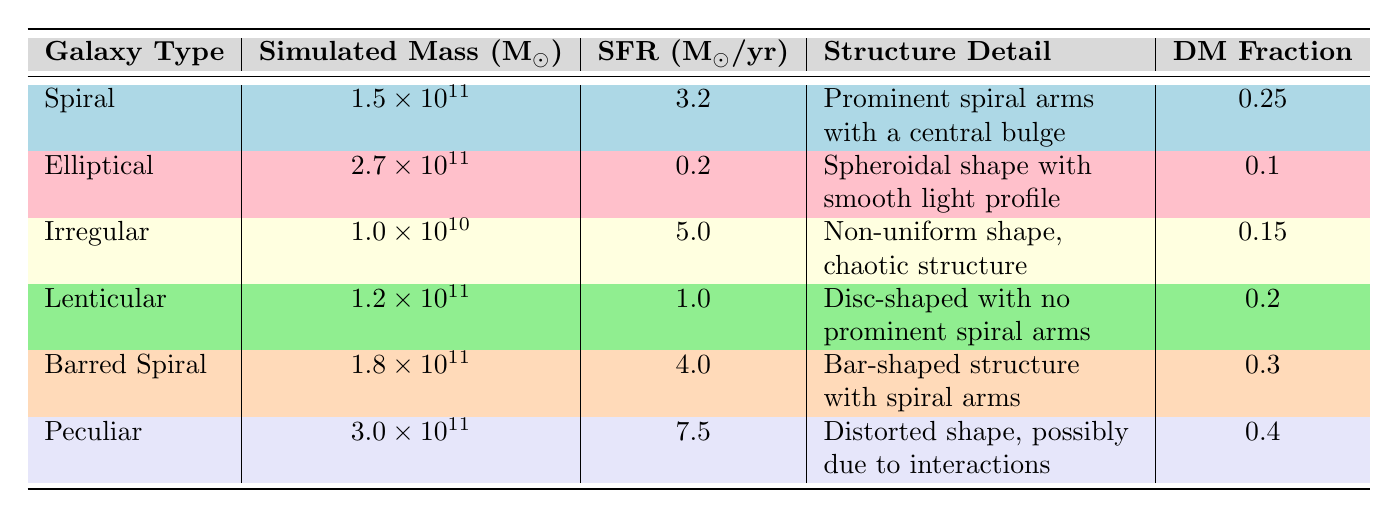What is the structure detail of the Spiral galaxy? According to the table, the structure detail for the Spiral galaxy is described as "Prominent spiral arms with a central bulge".
Answer: Prominent spiral arms with a central bulge What is the Dark Matter Fraction for the Peculiar galaxy? The Dark Matter Fraction for the Peculiar galaxy, as listed in the table, is 0.4.
Answer: 0.4 Which galaxy type has the highest Star Formation Rate? From the table, the Peculiar galaxy has the highest Star Formation Rate at 7.5 M☉/year. Other galaxy types have lower rates.
Answer: Peculiar How does the simulated mass compare between the Elliptical and the Lenticular galaxies? The simulated mass of the Elliptical galaxy is 2.7 x 10^11 M☉, while the Lenticular galaxy has a simulated mass of 1.2 x 10^11 M☉. The difference is 2.7 - 1.2 = 1.5 x 10^11 M☉.
Answer: 1.5 x 10^11 M☉ Is the Star Formation Rate for the Barred Spiral galaxy greater than that of the Spiral galaxy? The Star Formation Rate for the Barred Spiral is 4.0 M☉/year, while for the Spiral galaxy it is 3.2 M☉/year. Since 4.0 > 3.2, the statement is true.
Answer: Yes What is the average Dark Matter Fraction for all the galaxies listed? The Dark Matter Fractions are 0.25, 0.1, 0.15, 0.2, 0.3, and 0.4. To find the average, we sum these values: 0.25 + 0.1 + 0.15 + 0.2 + 0.3 + 0.4 = 1.4. There are 6 galaxies, so the average is 1.4 / 6 = 0.2333 (repeating).
Answer: 0.2333 Which galaxy types have simulated masses less than 1.5 x 10^11 M☉? The galaxies with simulated masses below 1.5 x 10^11 M☉ are the Irregular galaxy (1.0 x 10^10 M☉) and the Lenticular galaxy (1.2 x 10^11 M☉). There are two such types.
Answer: Irregular, Lenticular List the galaxy types that have a Star Formation Rate above 4 M☉/year. According to the table, the galaxies with a Star Formation Rate above 4 M☉/year are the Peculiar galaxy (7.5 M☉/year) and the Barred Spiral galaxy (4.0 M☉/year). Therefore, both are included.
Answer: Peculiar, Barred Spiral Does the Irregular galaxy have a lower Dark Matter Fraction than the Elliptical galaxy? The Dark Matter Fraction for the Irregular galaxy is 0.15, while for the Elliptical galaxy it is 0.1. Since 0.15 is greater than 0.1, the statement is false.
Answer: No 